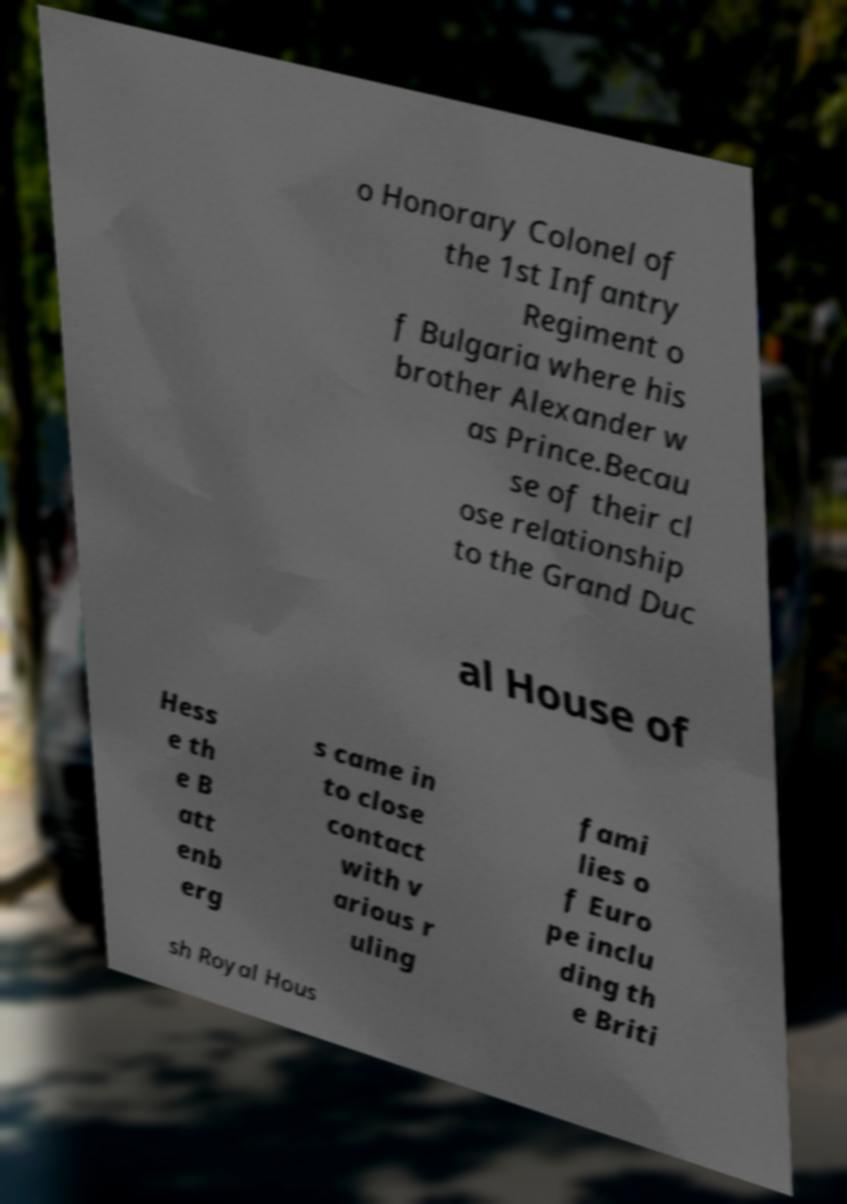Could you assist in decoding the text presented in this image and type it out clearly? o Honorary Colonel of the 1st Infantry Regiment o f Bulgaria where his brother Alexander w as Prince.Becau se of their cl ose relationship to the Grand Duc al House of Hess e th e B att enb erg s came in to close contact with v arious r uling fami lies o f Euro pe inclu ding th e Briti sh Royal Hous 